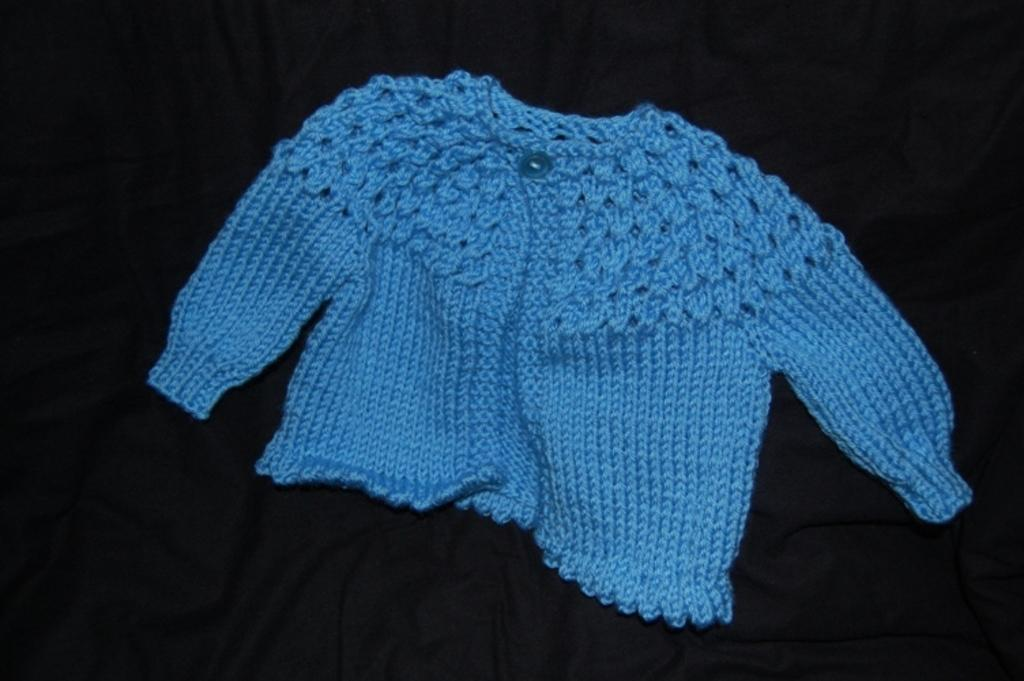What type of clothing item is visible in the image? There is a blue color sweater in the image. What is the sweater placed on? The sweater is placed on a black color cloth. What is the name of the person wearing the sweater in the image? There is no person visible in the image, only the sweater and the black color cloth. 